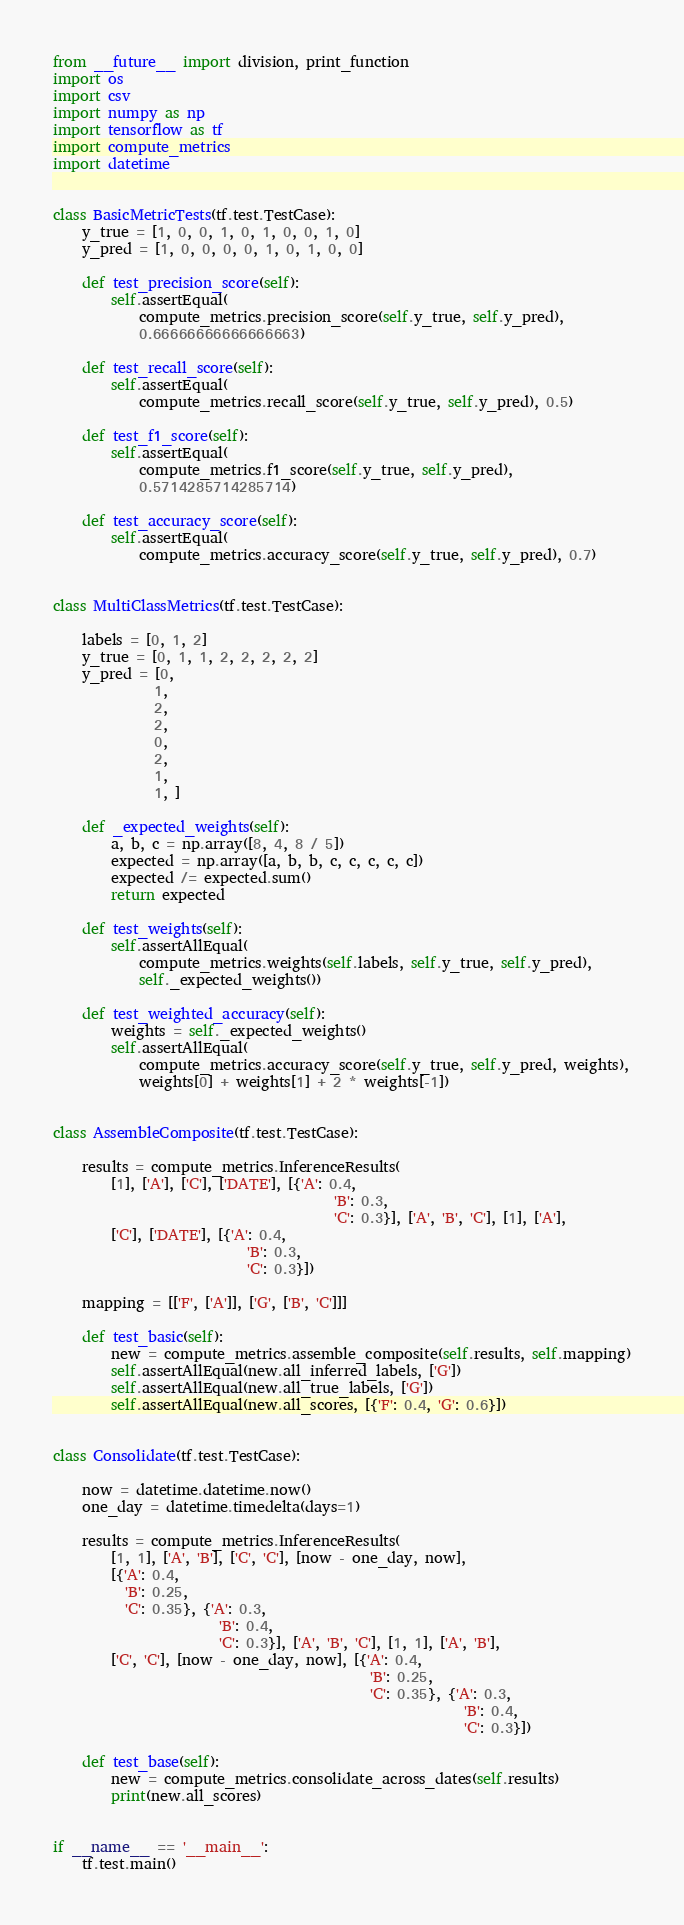<code> <loc_0><loc_0><loc_500><loc_500><_Python_>from __future__ import division, print_function
import os
import csv
import numpy as np
import tensorflow as tf
import compute_metrics
import datetime


class BasicMetricTests(tf.test.TestCase):
    y_true = [1, 0, 0, 1, 0, 1, 0, 0, 1, 0]
    y_pred = [1, 0, 0, 0, 0, 1, 0, 1, 0, 0]

    def test_precision_score(self):
        self.assertEqual(
            compute_metrics.precision_score(self.y_true, self.y_pred),
            0.66666666666666663)

    def test_recall_score(self):
        self.assertEqual(
            compute_metrics.recall_score(self.y_true, self.y_pred), 0.5)

    def test_f1_score(self):
        self.assertEqual(
            compute_metrics.f1_score(self.y_true, self.y_pred),
            0.5714285714285714)

    def test_accuracy_score(self):
        self.assertEqual(
            compute_metrics.accuracy_score(self.y_true, self.y_pred), 0.7)


class MultiClassMetrics(tf.test.TestCase):

    labels = [0, 1, 2]
    y_true = [0, 1, 1, 2, 2, 2, 2, 2]
    y_pred = [0,
              1,
              2,
              2,
              0,
              2,
              1,
              1, ]

    def _expected_weights(self):
        a, b, c = np.array([8, 4, 8 / 5])
        expected = np.array([a, b, b, c, c, c, c, c])
        expected /= expected.sum()
        return expected

    def test_weights(self):
        self.assertAllEqual(
            compute_metrics.weights(self.labels, self.y_true, self.y_pred),
            self._expected_weights())

    def test_weighted_accuracy(self):
        weights = self._expected_weights()
        self.assertAllEqual(
            compute_metrics.accuracy_score(self.y_true, self.y_pred, weights),
            weights[0] + weights[1] + 2 * weights[-1])


class AssembleComposite(tf.test.TestCase):

    results = compute_metrics.InferenceResults(
        [1], ['A'], ['C'], ['DATE'], [{'A': 0.4,
                                       'B': 0.3,
                                       'C': 0.3}], ['A', 'B', 'C'], [1], ['A'],
        ['C'], ['DATE'], [{'A': 0.4,
                           'B': 0.3,
                           'C': 0.3}])

    mapping = [['F', ['A']], ['G', ['B', 'C']]]

    def test_basic(self):
        new = compute_metrics.assemble_composite(self.results, self.mapping)
        self.assertAllEqual(new.all_inferred_labels, ['G'])
        self.assertAllEqual(new.all_true_labels, ['G'])
        self.assertAllEqual(new.all_scores, [{'F': 0.4, 'G': 0.6}])


class Consolidate(tf.test.TestCase):

    now = datetime.datetime.now()
    one_day = datetime.timedelta(days=1)

    results = compute_metrics.InferenceResults(
        [1, 1], ['A', 'B'], ['C', 'C'], [now - one_day, now],
        [{'A': 0.4,
          'B': 0.25,
          'C': 0.35}, {'A': 0.3,
                       'B': 0.4,
                       'C': 0.3}], ['A', 'B', 'C'], [1, 1], ['A', 'B'],
        ['C', 'C'], [now - one_day, now], [{'A': 0.4,
                                            'B': 0.25,
                                            'C': 0.35}, {'A': 0.3,
                                                         'B': 0.4,
                                                         'C': 0.3}])

    def test_base(self):
        new = compute_metrics.consolidate_across_dates(self.results)
        print(new.all_scores)


if __name__ == '__main__':
    tf.test.main()
</code> 